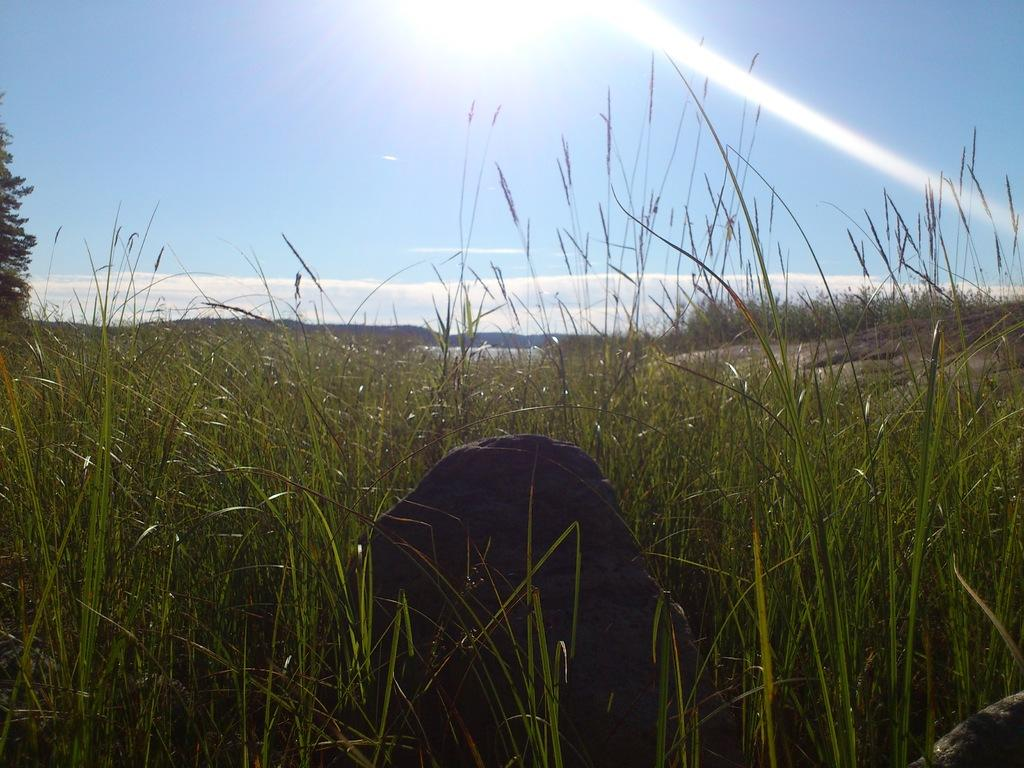What is the main object in the image? There is a stone in the image. What type of ground is visible in the image? There is grass on the ground in the image. What can be seen on the left side of the image? There is a tree on the left side of the image. What is visible in the background of the image? The sky is visible in the background of the image. What are the weather conditions like in the image? The sky has clouds and the sun is visible, indicating partly cloudy weather. What type of coat is the stone wearing in the image? There is no coat present in the image, as the stone is an inanimate object and does not wear clothing. 